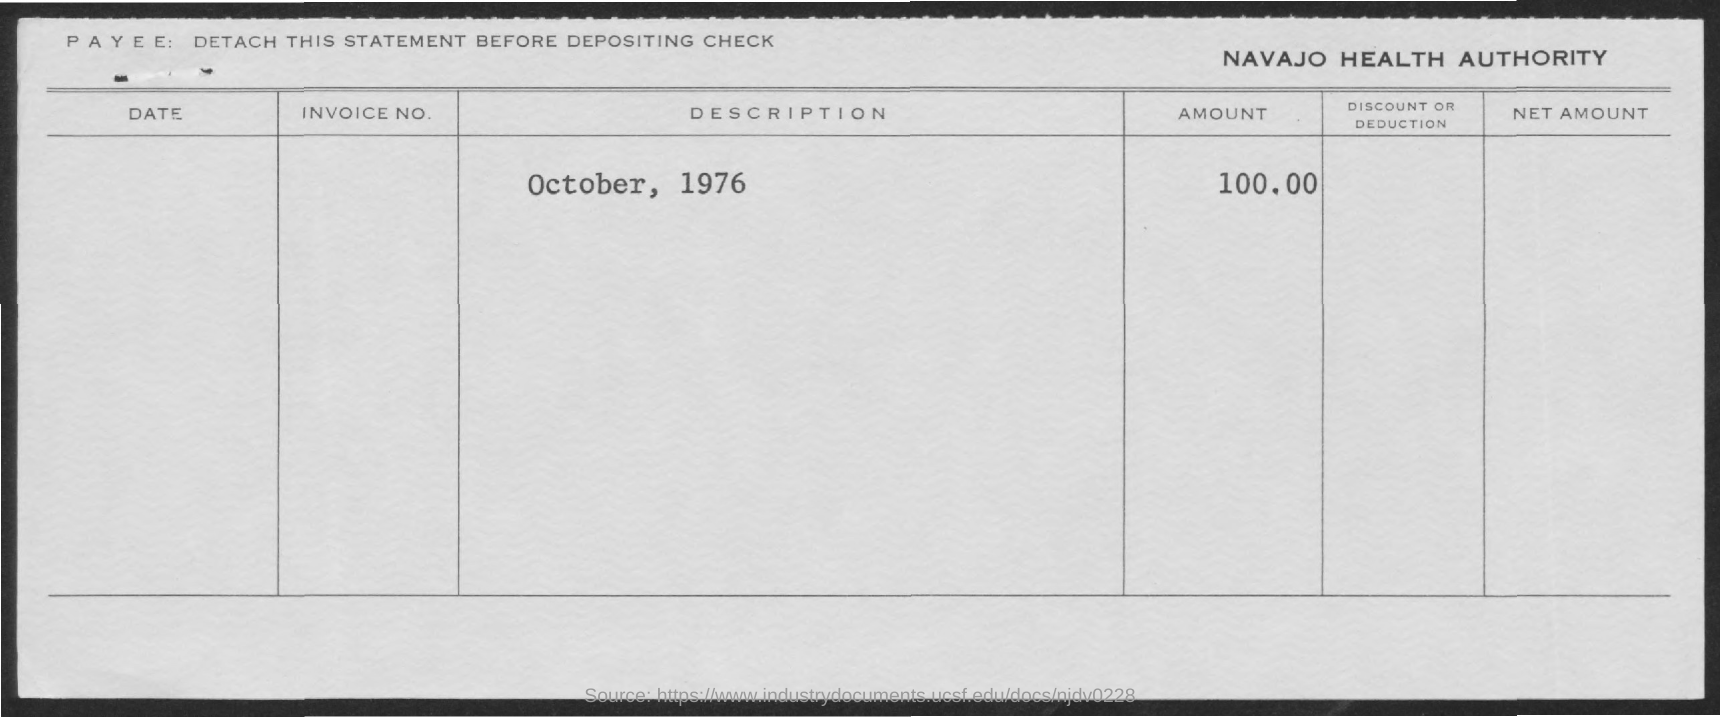Specify some key components in this picture. The amount is 100.00. The date mentioned is October, 1976. The Navajo Health Authority is the authority in question. 